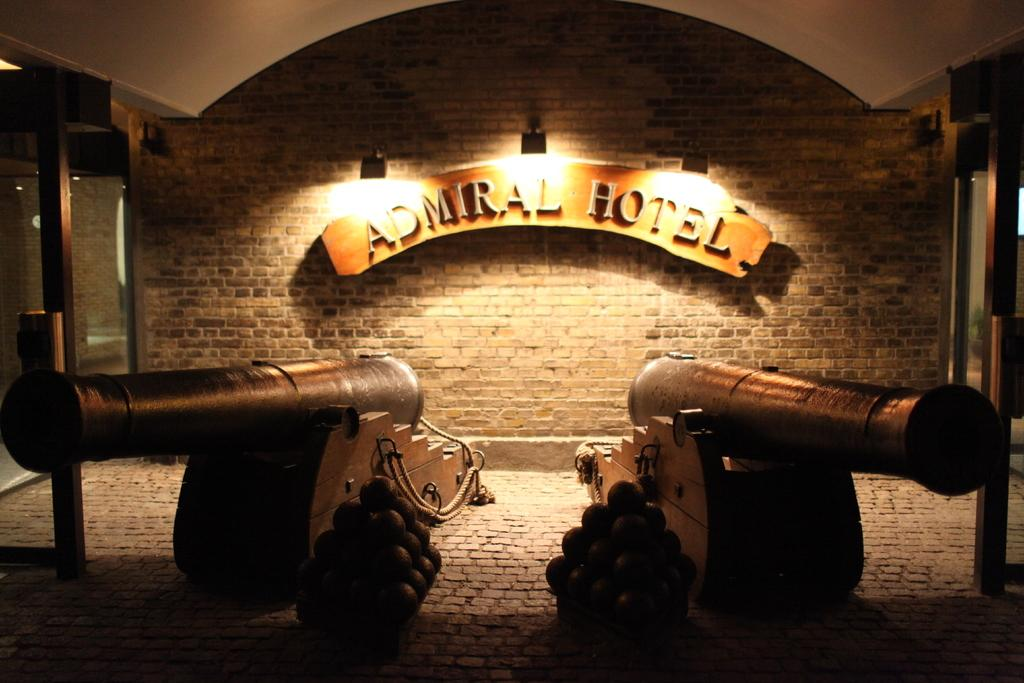What objects are present in the image that can be used for firing projectiles? There are canons in the image. What other objects can be seen in the image? There are balls in the image. What can be seen in the background of the image? There is a board, lights, and a brick wall in the background of the image. What type of rice is being used to create the border in the image? There is no rice or border present in the image. 